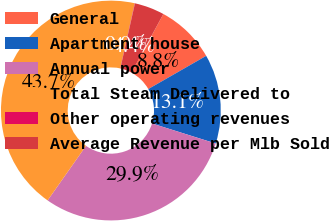<chart> <loc_0><loc_0><loc_500><loc_500><pie_chart><fcel>General<fcel>Apartment house<fcel>Annual power<fcel>Total Steam Delivered to<fcel>Other operating revenues<fcel>Average Revenue per Mlb Sold<nl><fcel>8.78%<fcel>13.14%<fcel>29.91%<fcel>43.72%<fcel>0.04%<fcel>4.41%<nl></chart> 